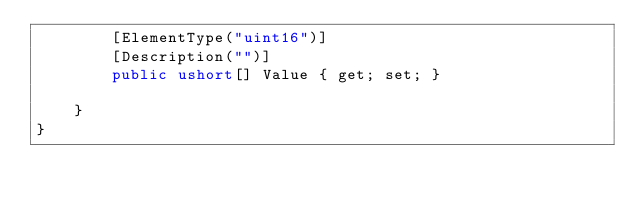<code> <loc_0><loc_0><loc_500><loc_500><_C#_>        [ElementType("uint16")]
        [Description("")]
        public ushort[] Value { get; set; }
        
    }
}
</code> 